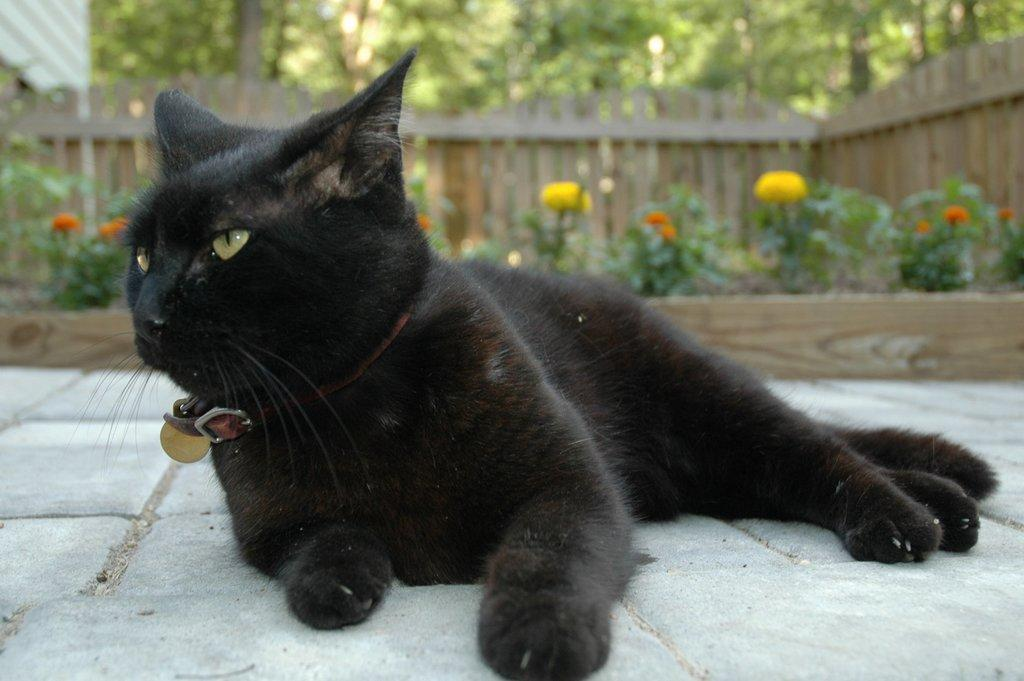What is the main subject in the center of the image? There is a cat in the center of the image. What can be seen in the background of the image? There are plants, flowers, and trees visible in the background of the image. What type of barrier is present in the image? There is a fence in the image. What type of argument is taking place between the cat and the flowers in the image? There is no argument present in the image; it features a cat and various plants and flowers. What type of metal is the fence made of in the image? The type of metal the fence is made of cannot be determined from the image, as it does not provide information about the material of the fence. 